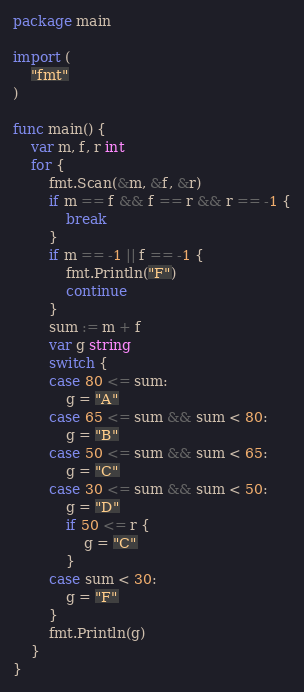Convert code to text. <code><loc_0><loc_0><loc_500><loc_500><_Go_>package main

import (
	"fmt"
)

func main() {
	var m, f, r int
	for {
		fmt.Scan(&m, &f, &r)
		if m == f && f == r && r == -1 {
			break
		}
		if m == -1 || f == -1 {
			fmt.Println("F")
            continue
		}
		sum := m + f
		var g string
		switch {
		case 80 <= sum:
			g = "A"
		case 65 <= sum && sum < 80:
			g = "B"
		case 50 <= sum && sum < 65:
			g = "C"
		case 30 <= sum && sum < 50:
			g = "D"
			if 50 <= r {
				g = "C"
			}
		case sum < 30:
			g = "F"
		}
		fmt.Println(g)
	}
}

</code> 